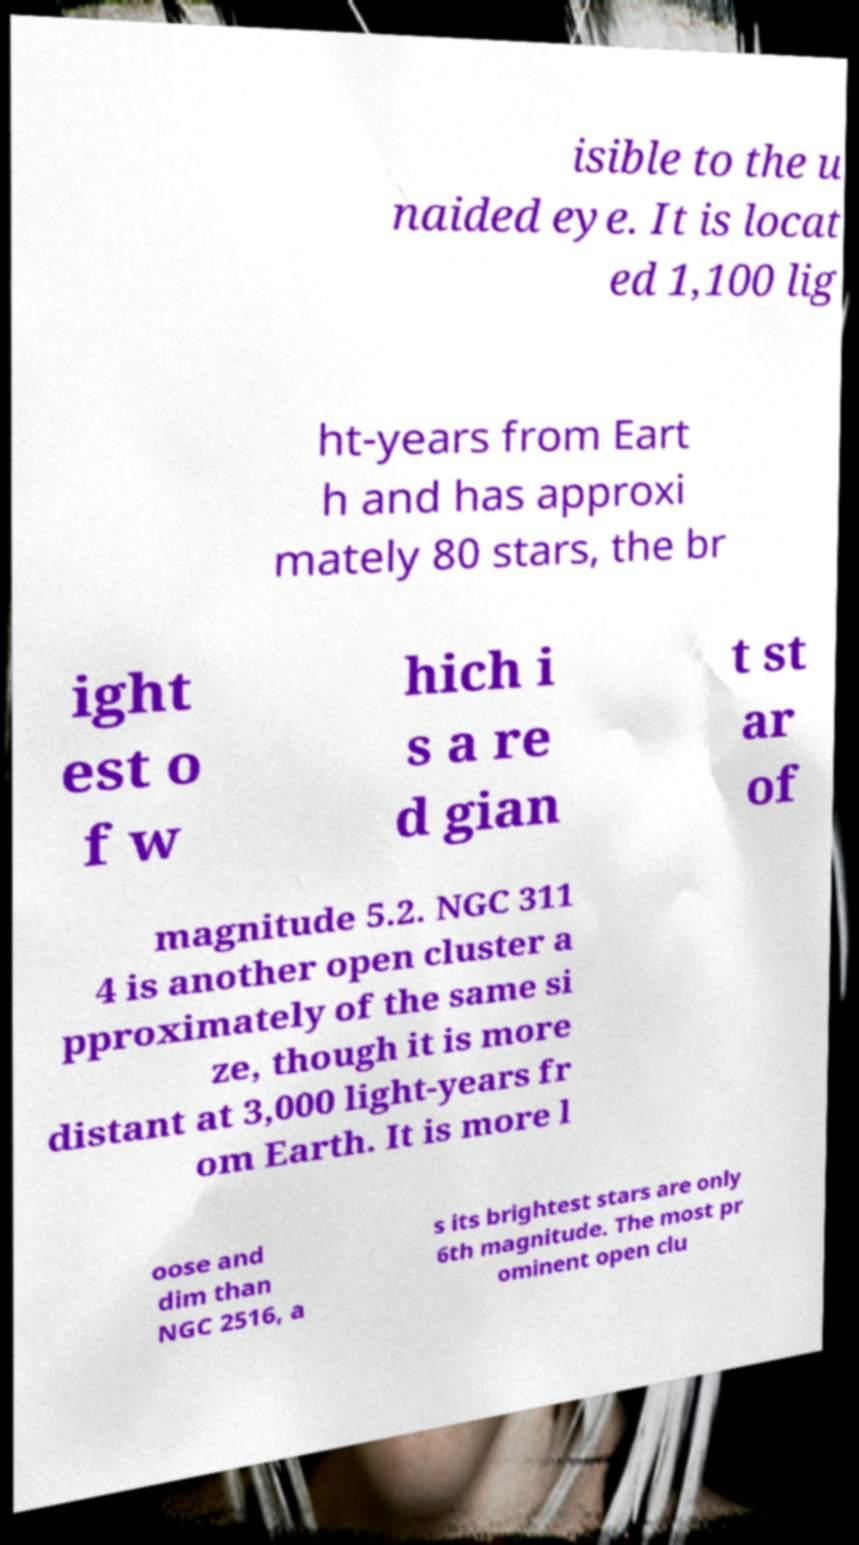Please read and relay the text visible in this image. What does it say? isible to the u naided eye. It is locat ed 1,100 lig ht-years from Eart h and has approxi mately 80 stars, the br ight est o f w hich i s a re d gian t st ar of magnitude 5.2. NGC 311 4 is another open cluster a pproximately of the same si ze, though it is more distant at 3,000 light-years fr om Earth. It is more l oose and dim than NGC 2516, a s its brightest stars are only 6th magnitude. The most pr ominent open clu 